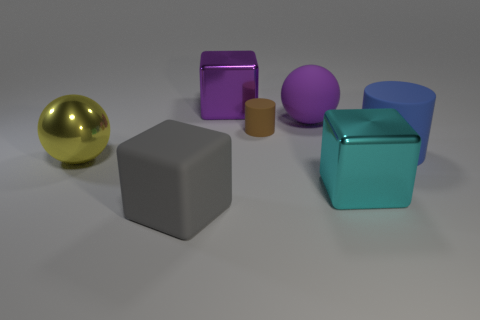Subtract all metal cubes. How many cubes are left? 1 Add 2 large cylinders. How many objects exist? 9 Subtract all brown cylinders. How many cylinders are left? 1 Subtract all green cylinders. How many red balls are left? 0 Subtract all tiny rubber cylinders. Subtract all small rubber cylinders. How many objects are left? 5 Add 3 large purple shiny things. How many large purple shiny things are left? 4 Add 4 tiny matte cylinders. How many tiny matte cylinders exist? 5 Subtract 0 green cylinders. How many objects are left? 7 Subtract all balls. How many objects are left? 5 Subtract 2 blocks. How many blocks are left? 1 